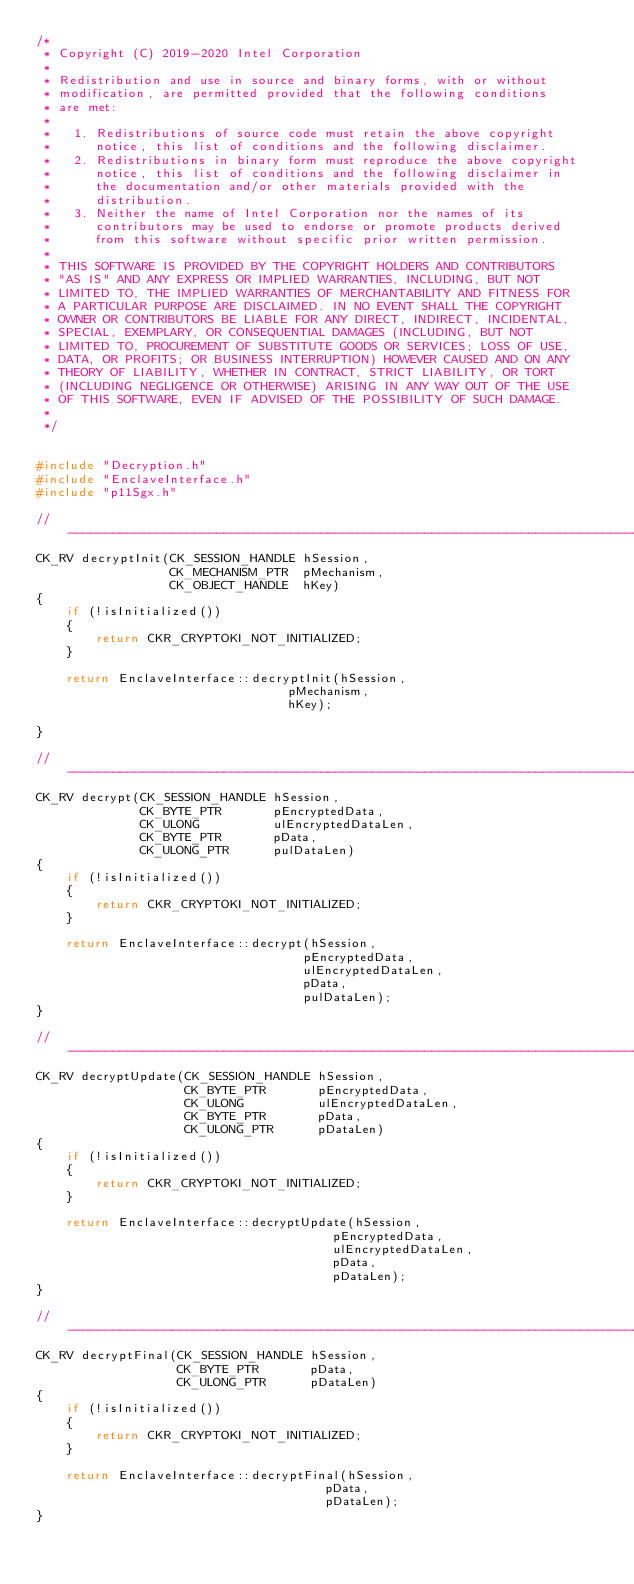Convert code to text. <code><loc_0><loc_0><loc_500><loc_500><_C++_>/*
 * Copyright (C) 2019-2020 Intel Corporation
 *
 * Redistribution and use in source and binary forms, with or without
 * modification, are permitted provided that the following conditions
 * are met:
 *
 *   1. Redistributions of source code must retain the above copyright
 *      notice, this list of conditions and the following disclaimer.
 *   2. Redistributions in binary form must reproduce the above copyright
 *      notice, this list of conditions and the following disclaimer in
 *      the documentation and/or other materials provided with the
 *      distribution.
 *   3. Neither the name of Intel Corporation nor the names of its
 *      contributors may be used to endorse or promote products derived
 *      from this software without specific prior written permission.
 *
 * THIS SOFTWARE IS PROVIDED BY THE COPYRIGHT HOLDERS AND CONTRIBUTORS
 * "AS IS" AND ANY EXPRESS OR IMPLIED WARRANTIES, INCLUDING, BUT NOT
 * LIMITED TO, THE IMPLIED WARRANTIES OF MERCHANTABILITY AND FITNESS FOR
 * A PARTICULAR PURPOSE ARE DISCLAIMED. IN NO EVENT SHALL THE COPYRIGHT
 * OWNER OR CONTRIBUTORS BE LIABLE FOR ANY DIRECT, INDIRECT, INCIDENTAL,
 * SPECIAL, EXEMPLARY, OR CONSEQUENTIAL DAMAGES (INCLUDING, BUT NOT
 * LIMITED TO, PROCUREMENT OF SUBSTITUTE GOODS OR SERVICES; LOSS OF USE,
 * DATA, OR PROFITS; OR BUSINESS INTERRUPTION) HOWEVER CAUSED AND ON ANY
 * THEORY OF LIABILITY, WHETHER IN CONTRACT, STRICT LIABILITY, OR TORT
 * (INCLUDING NEGLIGENCE OR OTHERWISE) ARISING IN ANY WAY OUT OF THE USE
 * OF THIS SOFTWARE, EVEN IF ADVISED OF THE POSSIBILITY OF SUCH DAMAGE.
 *
 */


#include "Decryption.h"
#include "EnclaveInterface.h"
#include "p11Sgx.h"

//---------------------------------------------------------------------------------------------
CK_RV decryptInit(CK_SESSION_HANDLE hSession,
                  CK_MECHANISM_PTR  pMechanism,
                  CK_OBJECT_HANDLE  hKey)
{
    if (!isInitialized())
    {
        return CKR_CRYPTOKI_NOT_INITIALIZED;
    }

    return EnclaveInterface::decryptInit(hSession,
                                  pMechanism,
                                  hKey);

}

//---------------------------------------------------------------------------------------------
CK_RV decrypt(CK_SESSION_HANDLE hSession,
              CK_BYTE_PTR       pEncryptedData,
              CK_ULONG          ulEncryptedDataLen,
              CK_BYTE_PTR       pData,
              CK_ULONG_PTR      pulDataLen)
{
    if (!isInitialized())
    {
        return CKR_CRYPTOKI_NOT_INITIALIZED;
    }

    return EnclaveInterface::decrypt(hSession,
                                    pEncryptedData,
                                    ulEncryptedDataLen,
                                    pData,
                                    pulDataLen);
}

//---------------------------------------------------------------------------------------------
CK_RV decryptUpdate(CK_SESSION_HANDLE hSession,
                    CK_BYTE_PTR       pEncryptedData,
                    CK_ULONG          ulEncryptedDataLen,
                    CK_BYTE_PTR       pData,
                    CK_ULONG_PTR      pDataLen)
{
    if (!isInitialized())
    {
        return CKR_CRYPTOKI_NOT_INITIALIZED;
    }

    return EnclaveInterface::decryptUpdate(hSession,
                                        pEncryptedData,
                                        ulEncryptedDataLen,
                                        pData,
                                        pDataLen);
}

//---------------------------------------------------------------------------------------------
CK_RV decryptFinal(CK_SESSION_HANDLE hSession,
                   CK_BYTE_PTR       pData,
                   CK_ULONG_PTR      pDataLen)
{
    if (!isInitialized())
    {
        return CKR_CRYPTOKI_NOT_INITIALIZED;
    }

    return EnclaveInterface::decryptFinal(hSession,
                                       pData,
                                       pDataLen);
}</code> 